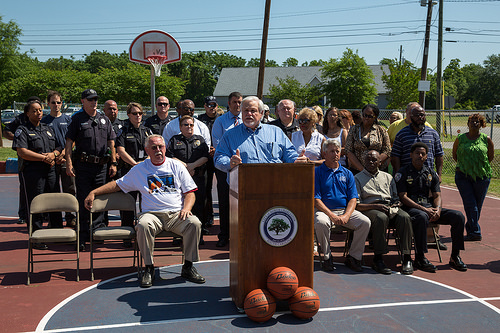<image>
Can you confirm if the old man is on the old lady? No. The old man is not positioned on the old lady. They may be near each other, but the old man is not supported by or resting on top of the old lady. Is there a balls in front of the man? Yes. The balls is positioned in front of the man, appearing closer to the camera viewpoint. 